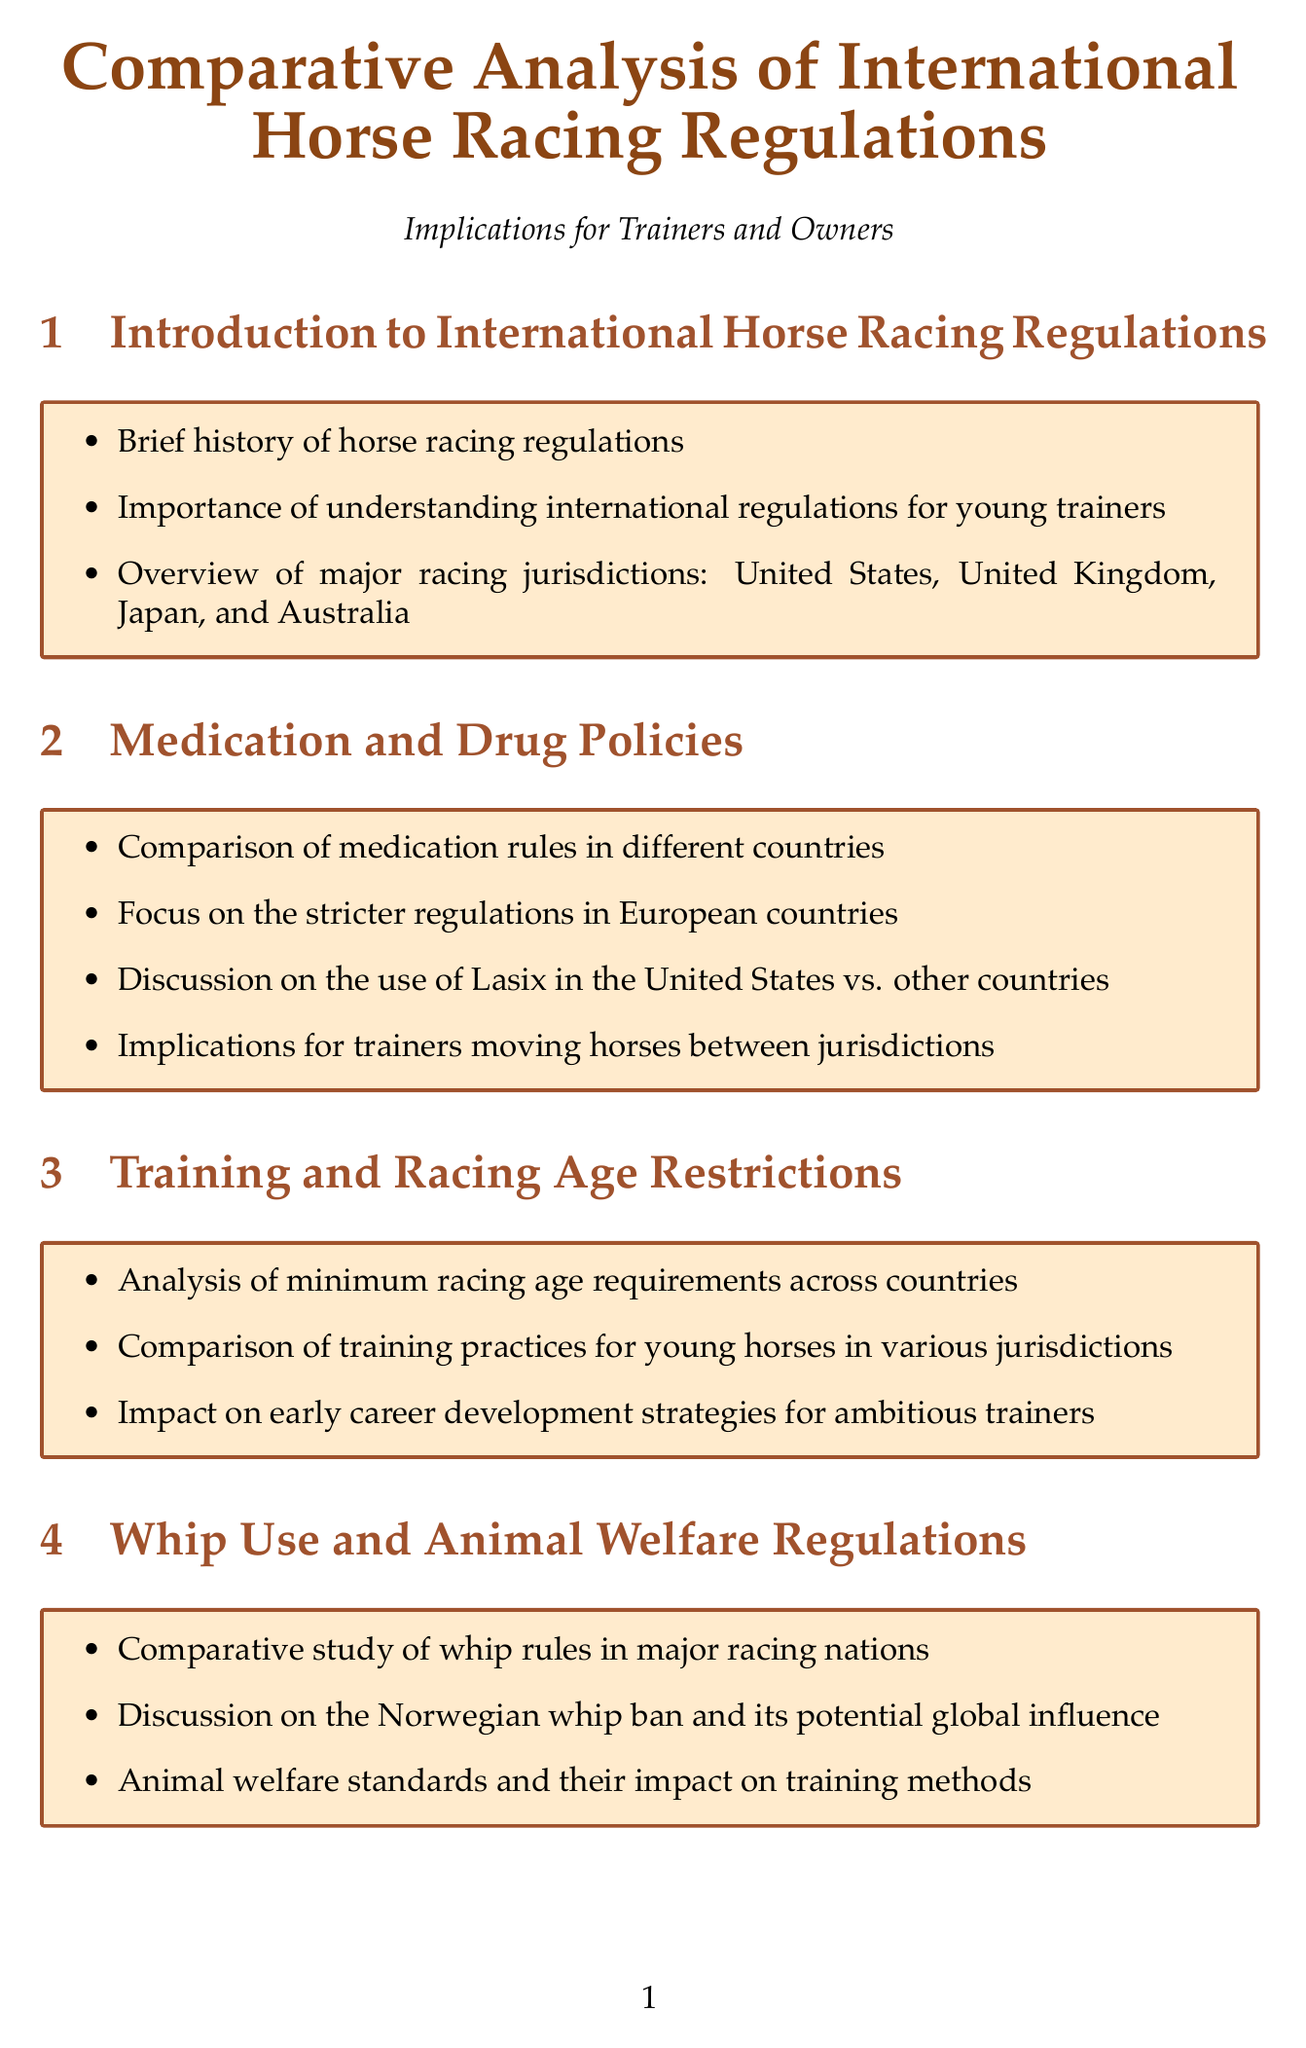What are the major racing jurisdictions? The major racing jurisdictions mentioned in the document are the United States, United Kingdom, Japan, and Australia.
Answer: United States, United Kingdom, Japan, Australia What is discussed regarding the use of Lasix? The document discusses the differences in the use of Lasix in the United States compared to other countries.
Answer: Use of Lasix What are the minimum racing age requirements? The document provides an analysis of minimum racing age requirements across various countries.
Answer: Varies by country What is the focus of the whip use section? The whip use section includes a comparative study of whip rules in major racing nations.
Answer: Comparative study of whip rules Which organization focuses on global medication standards? The International Federation of Horseracing Authorities (IFHA) is mentioned for its initiatives regarding global medication standards.
Answer: IFHA What are the implications of stallion shuttling discussed in the document? The document discusses the implications of stallion shuttling on breeding regulations and the global bloodstock market.
Answer: Stallion shuttling implications Who achieved success at Royal Ascot with American-trained horses? The document mentions Wesley Ward's success with American-trained horses at Royal Ascot.
Answer: Wesley Ward What is a major challenge for young trainers? One major challenge mentioned is the opportunities and challenges in seeking international experience through licensing processes.
Answer: Opportunities and challenges What is highlighted about race day procedures? The document highlights the comparison of pre-race inspections and veterinary checks across different jurisdictions.
Answer: Pre-race inspections and veterinary checks 